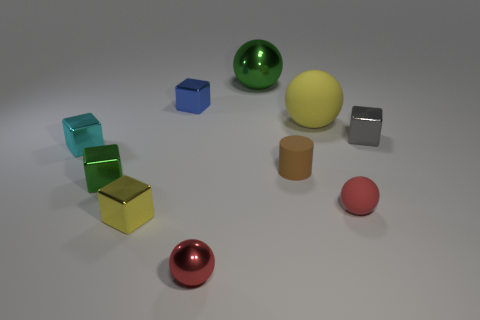There is a small rubber cylinder; is it the same color as the metal object that is to the right of the cylinder?
Offer a terse response. No. Is there a metal cube that has the same color as the matte cylinder?
Offer a terse response. No. Do the cyan block and the block that is right of the brown thing have the same material?
Ensure brevity in your answer.  Yes. How many large objects are gray shiny objects or blue metallic blocks?
Give a very brief answer. 0. There is another sphere that is the same color as the small metal sphere; what is its material?
Provide a succinct answer. Rubber. Is the number of small green rubber objects less than the number of red balls?
Your answer should be compact. Yes. There is a shiny object that is behind the tiny blue block; does it have the same size as the shiny ball in front of the small green thing?
Your answer should be compact. No. What number of gray objects are metal balls or big metal cubes?
Make the answer very short. 0. There is a metal block that is the same color as the big metallic sphere; what size is it?
Offer a very short reply. Small. Is the number of small matte blocks greater than the number of small yellow objects?
Provide a short and direct response. No. 